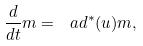Convert formula to latex. <formula><loc_0><loc_0><loc_500><loc_500>\frac { d } { d t } m = \ a d ^ { * } ( u ) m ,</formula> 